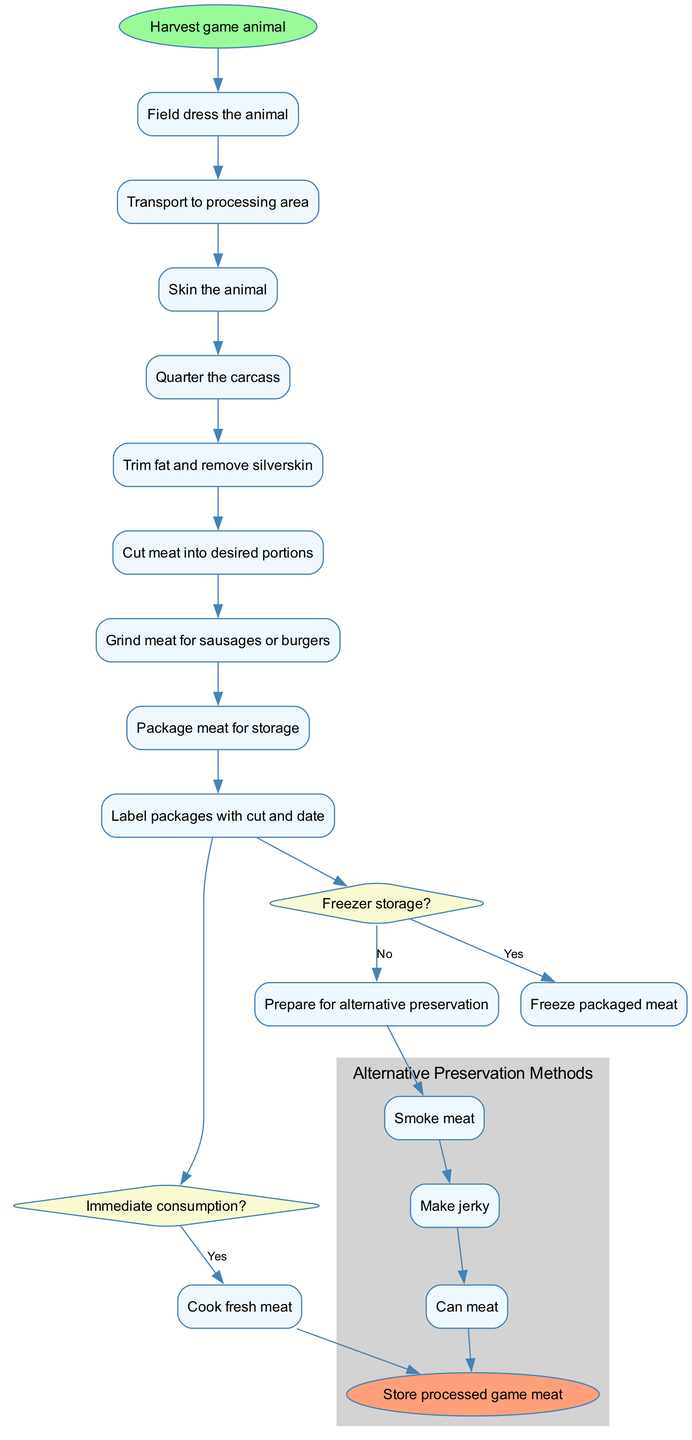What is the first activity in the diagram? The first activity node in the diagram is the one that directly connects from the start node labeled "Harvest game animal." This indicates the initial action taken in the process.
Answer: Harvest game animal How many activities are there in total? By counting each distinct activity node listed, there are a total of nine activities that follow the start node within the diagram.
Answer: 9 What are the two options after the "Field dress the animal" activity? After the "Field dress the animal" activity, the next activity node is "Transport to processing area," which then leads into "Skin the animal," corresponding to the sequence of tasks.
Answer: Transport to processing area, Skin the animal What happens if the answer is "no" to "Immediate consumption?" If the answer is "no," the diagram indicates that the next step is "Prepare for storage," which illustrates the process to transition into storage preparation activities instead of cooking.
Answer: Prepare for storage How many decision nodes are present in the diagram? The diagram contains two decision nodes, where each decision presents a question with yes or no options leading to different paths based on the responses.
Answer: 2 What method follows if "Freezer storage?" is answered "no"? If "Freezer storage?" is answered "no," the next activity will be "Prepare for alternative preservation," indicating the need for different preservation methods.
Answer: Prepare for alternative preservation Which activity directly leads to the end node? The pathway that leads directly to the end node connects through the "Freeze packaged meat" option after confirming freezer storage, showing the conclusion of processing meat for storage.
Answer: Freeze packaged meat List the alternative preservation methods. The diagram outlines three alternative preservation methods, which are specifically grouped as sub-activities shown in the cluster, indicating different ways to process meat.
Answer: Smoke meat, Make jerky, Can meat What shape are the decision nodes in the diagram? The decision nodes are distinctly shaped as diamonds, differentiating them visually from the rectangular activity nodes, signifying their role in the decision-making process.
Answer: Diamond 